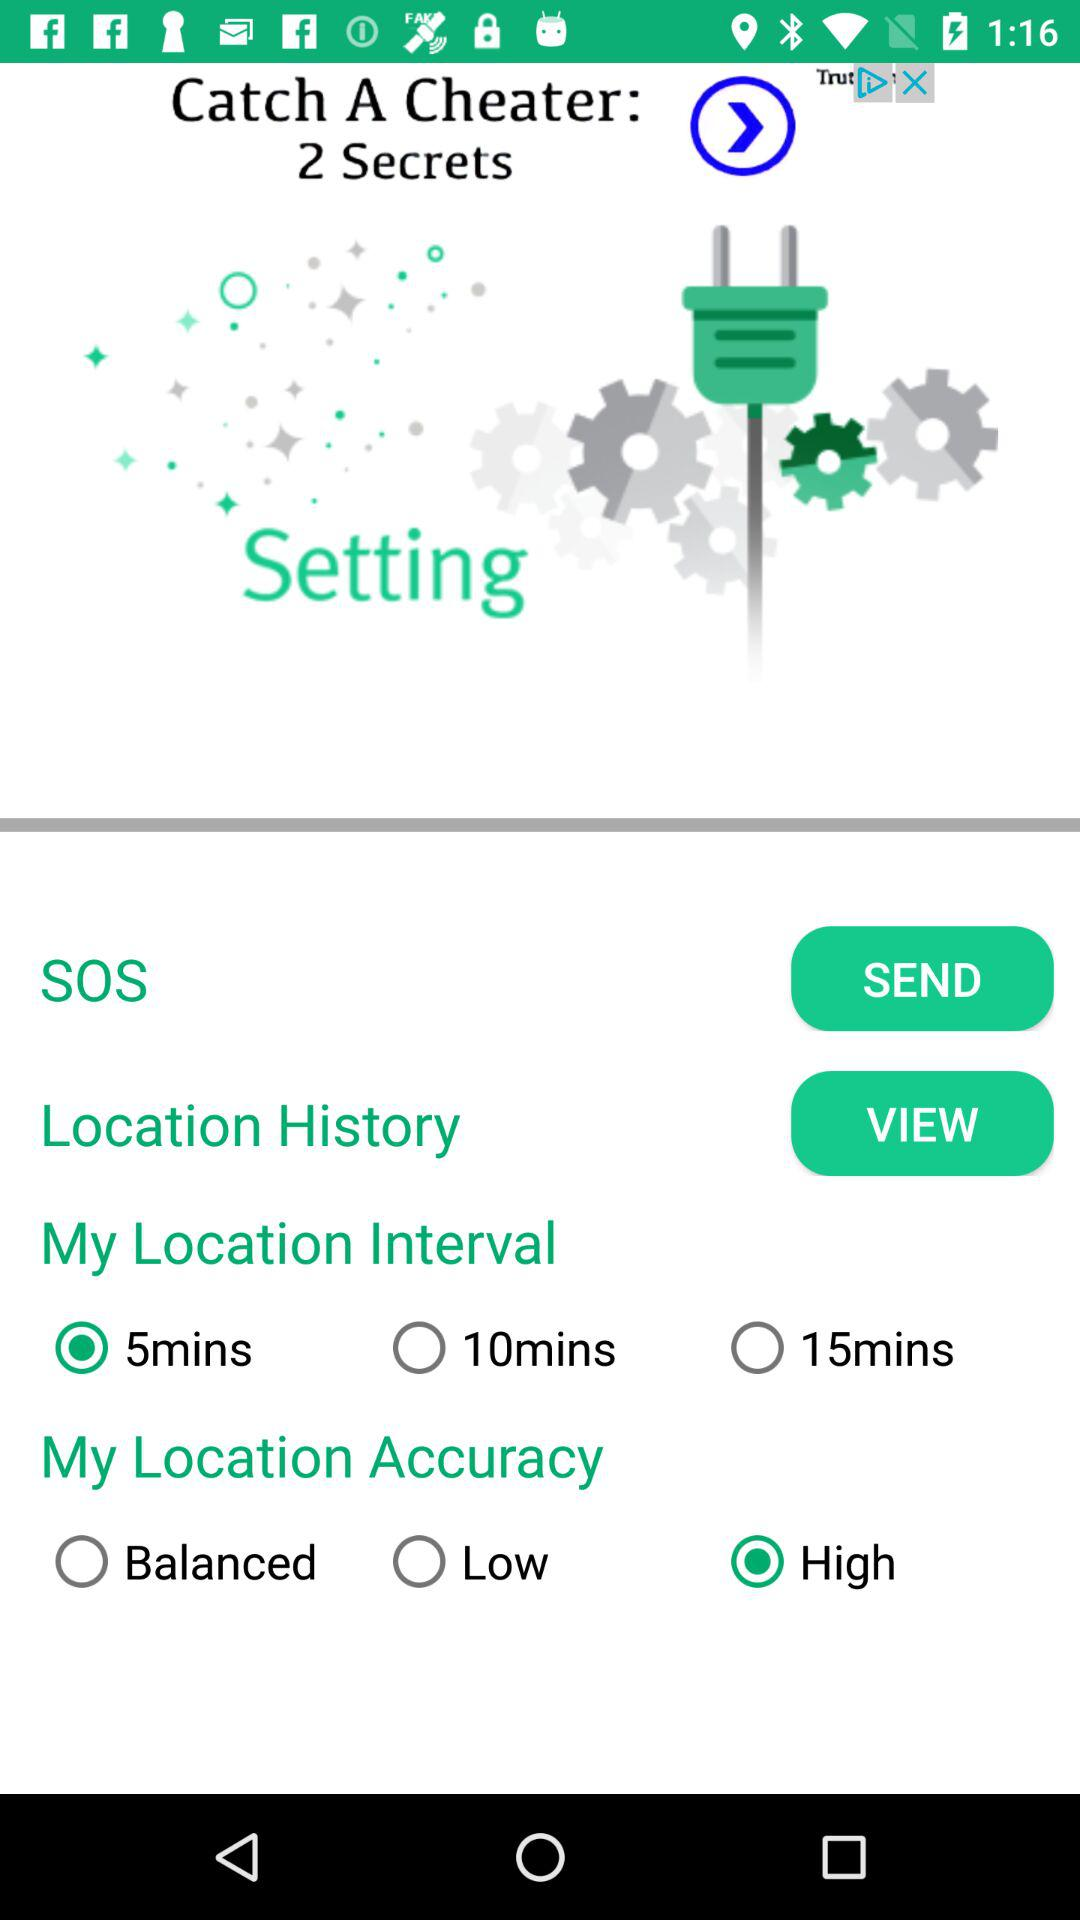What is the location accuracy? The location accuracy is "High". 